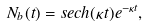Convert formula to latex. <formula><loc_0><loc_0><loc_500><loc_500>N _ { b } ( t ) = s e c h ( \kappa t ) e ^ { - \kappa t } ,</formula> 